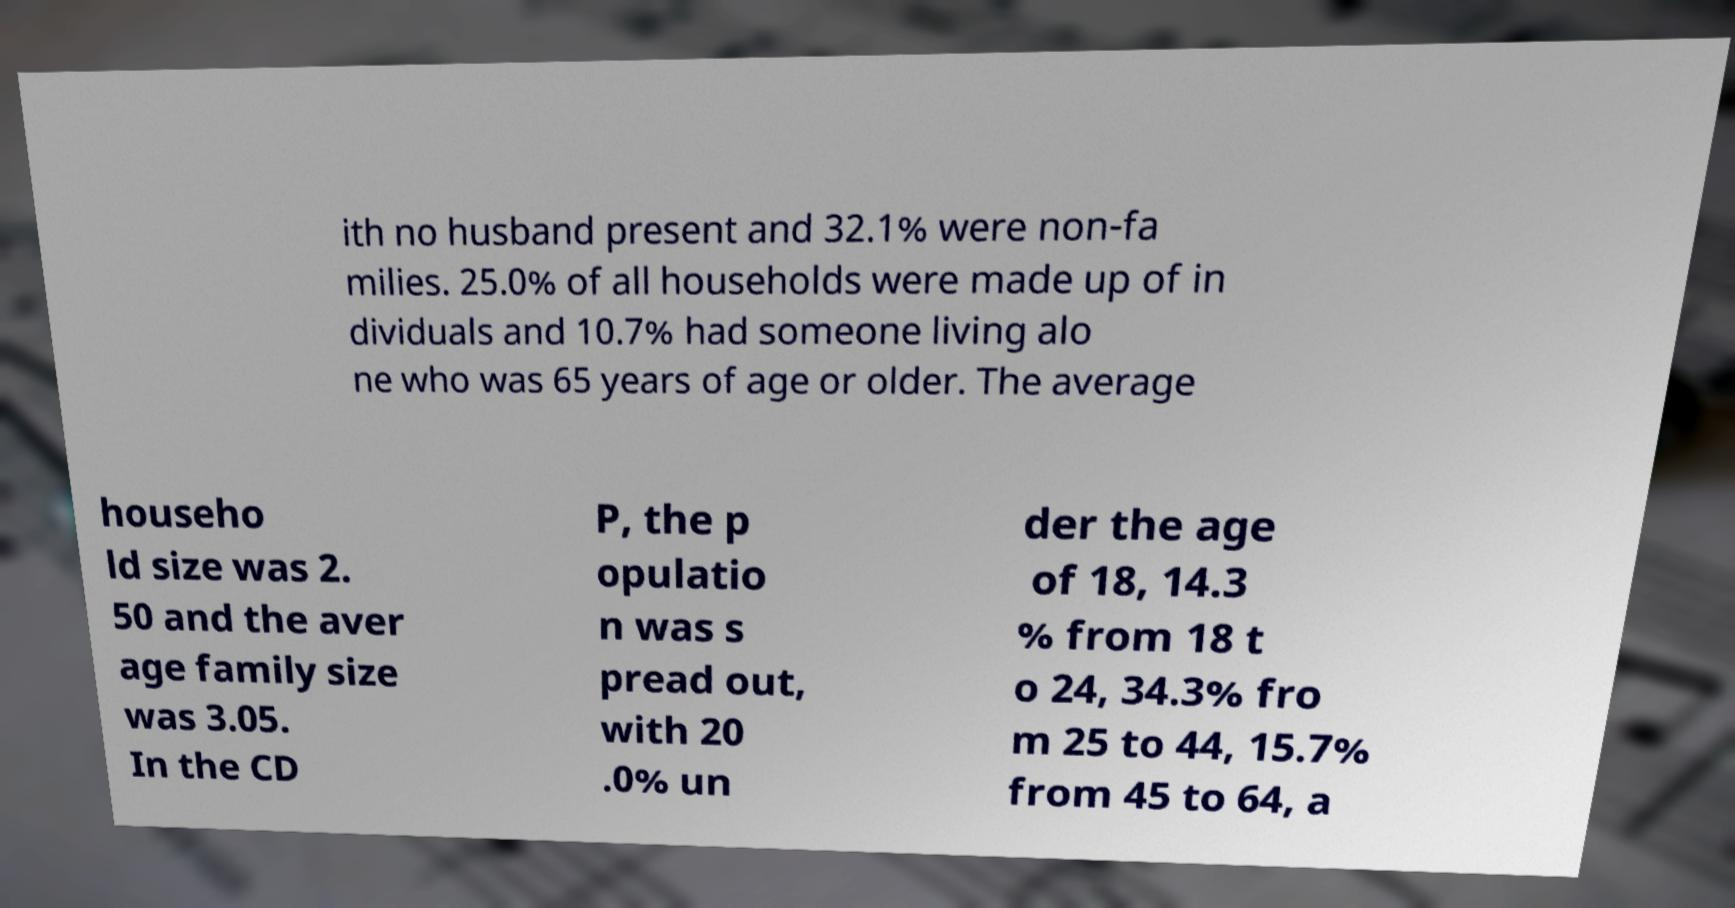Could you extract and type out the text from this image? ith no husband present and 32.1% were non-fa milies. 25.0% of all households were made up of in dividuals and 10.7% had someone living alo ne who was 65 years of age or older. The average househo ld size was 2. 50 and the aver age family size was 3.05. In the CD P, the p opulatio n was s pread out, with 20 .0% un der the age of 18, 14.3 % from 18 t o 24, 34.3% fro m 25 to 44, 15.7% from 45 to 64, a 